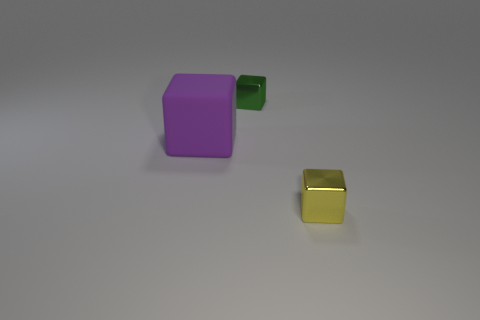Subtract all small cubes. How many cubes are left? 1 Subtract all green cubes. How many cubes are left? 2 Add 2 small brown metal blocks. How many objects exist? 5 Subtract 1 blocks. How many blocks are left? 2 Subtract 1 green blocks. How many objects are left? 2 Subtract all blue blocks. Subtract all yellow balls. How many blocks are left? 3 Subtract all green metal blocks. Subtract all tiny yellow rubber blocks. How many objects are left? 2 Add 2 small yellow objects. How many small yellow objects are left? 3 Add 2 purple rubber balls. How many purple rubber balls exist? 2 